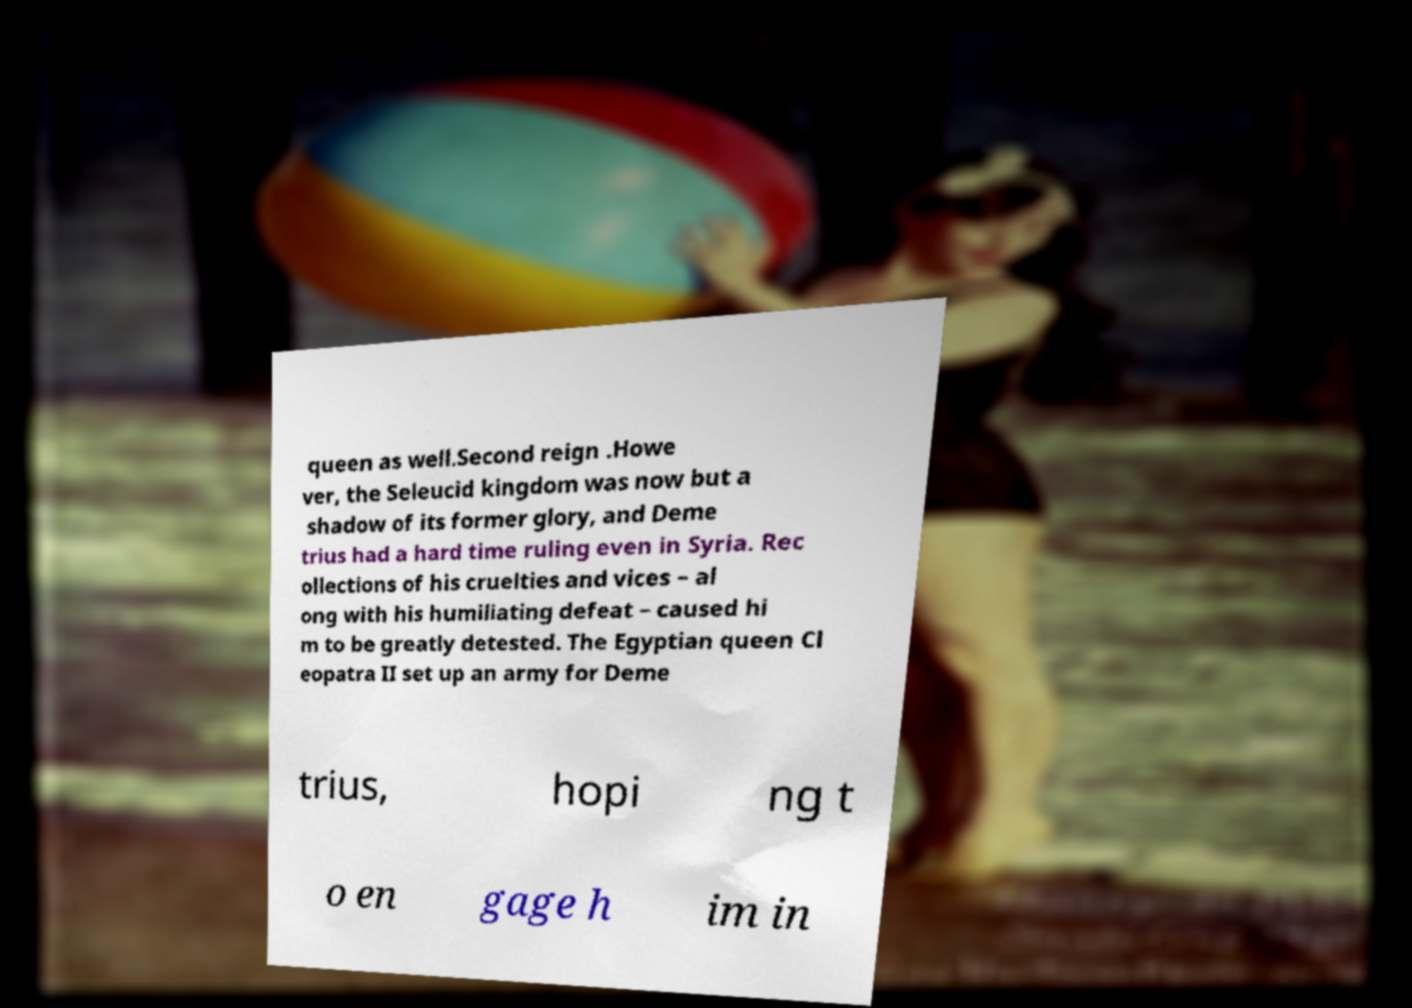Can you read and provide the text displayed in the image?This photo seems to have some interesting text. Can you extract and type it out for me? queen as well.Second reign .Howe ver, the Seleucid kingdom was now but a shadow of its former glory, and Deme trius had a hard time ruling even in Syria. Rec ollections of his cruelties and vices – al ong with his humiliating defeat – caused hi m to be greatly detested. The Egyptian queen Cl eopatra II set up an army for Deme trius, hopi ng t o en gage h im in 